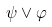<formula> <loc_0><loc_0><loc_500><loc_500>\psi \vee \varphi</formula> 